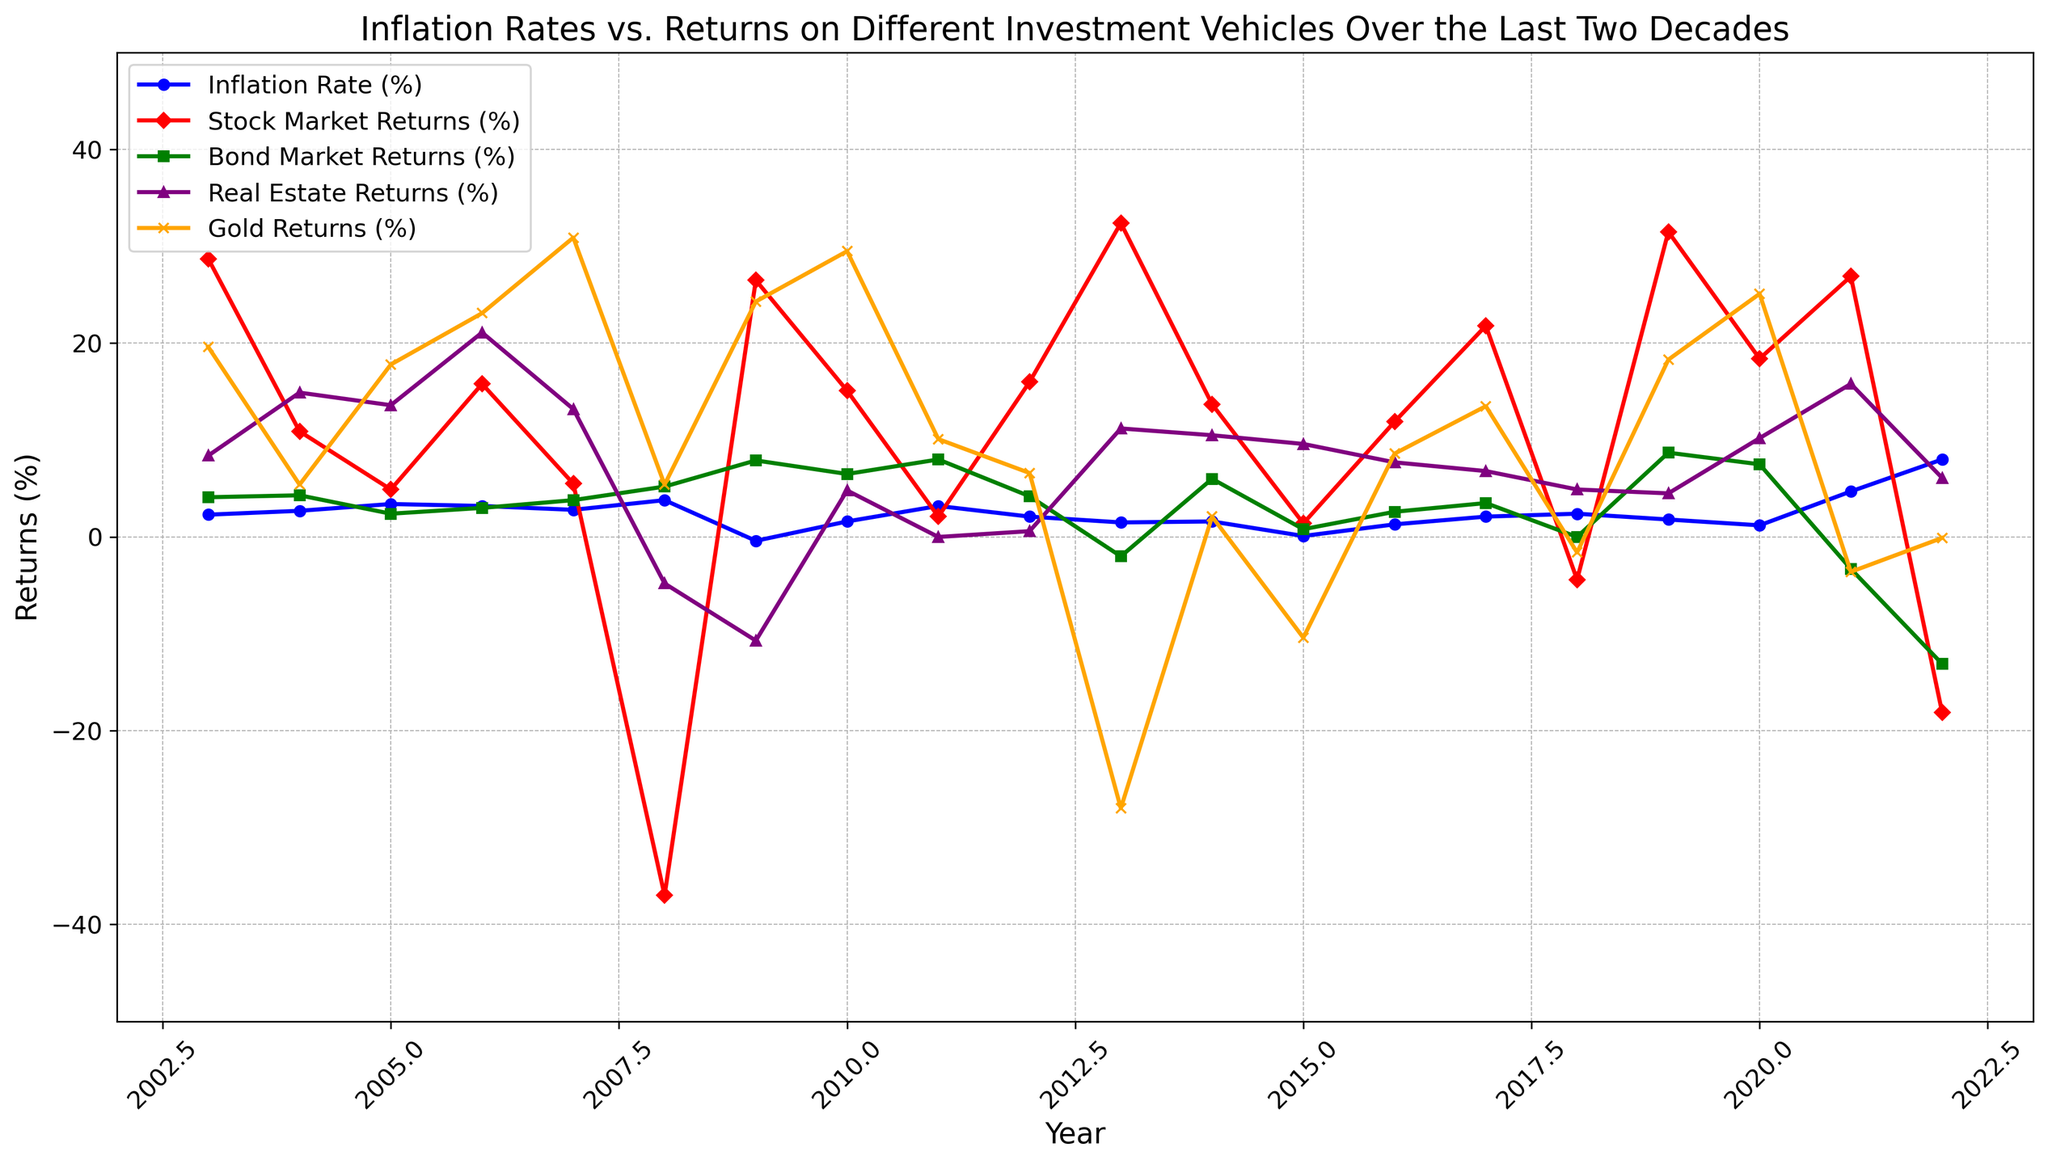What's the highest return for the stock market over the last two decades? Look at the peaks in the red line. The highest point for the stock market returns is in 2013.
Answer: 32.4% How did bond returns compare to inflation rates in 2008? Check both the green line (bond returns) and the blue line (inflation rates) in 2008. Bond returns were at 5.2%, while inflation was at 3.8%.
Answer: Bond returns were higher Which investment vehicle had the most negative return in 2022? Look at the lines in 2022. The investment vehicle with the most significant drop is where the line hits the lowest point. Here, the stock market (red line) had the most negative return at -18.1%.
Answer: Stock market What is the average return of the real estate market in 2020 and 2021? Find the real estate returns (purple line) for 2020 and 2021, which are 10.2% and 15.8%, and calculate the average: (10.2 + 15.8) / 2.
Answer: 13% During which year did gold returns have their highest increase compared to the previous year? Observe the orange line for the steepest upward slope. From 2011 to 2012, gold returns increased from 10.1% to 24.3%, a 14.2% increase.
Answer: 2012 Between 2007 and 2008, which investment vehicle experienced the greatest change in returns? Identify the steepest change in any of the lines between 2007 and 2008. The stock market (red line) dropped from 5.5% to -37.0%, the largest change of -42.5%.
Answer: Stock market Did any year have negative inflation, and what was the stock market return during that year? Check the blue line for any points below zero. In 2009, inflation was -0.4%, and the stock market return (red line) was 26.5%.
Answer: 2009, 26.5% How did gold returns in 2015 compare to 2016? Look at the orange line in 2015 and 2016. Gold returns were -10.4% in 2015 and 8.6% in 2016.
Answer: Higher in 2016 What was the difference between bond market returns in 2013 and 2022? Bond market returns were -2.0% in 2013 (green line) and -13.1% in 2022. The difference is -2.0 - (-13.1) = 11.1%.
Answer: 11.1% During the last two decades, did real estate returns ever drop below zero, and if so, in which year? Observe the purple line for any year it goes below zero. Real estate returns dipped below zero in 2008.
Answer: Yes, 2008 